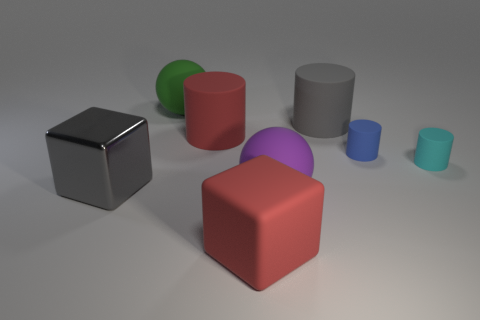Add 1 yellow metal cylinders. How many objects exist? 9 Subtract all red rubber cylinders. How many cylinders are left? 3 Subtract all red blocks. How many blocks are left? 1 Subtract all spheres. How many objects are left? 6 Subtract 1 blocks. How many blocks are left? 1 Subtract all tiny green shiny objects. Subtract all large gray blocks. How many objects are left? 7 Add 6 big red cylinders. How many big red cylinders are left? 7 Add 6 blue things. How many blue things exist? 7 Subtract 0 brown cylinders. How many objects are left? 8 Subtract all red balls. Subtract all red cylinders. How many balls are left? 2 